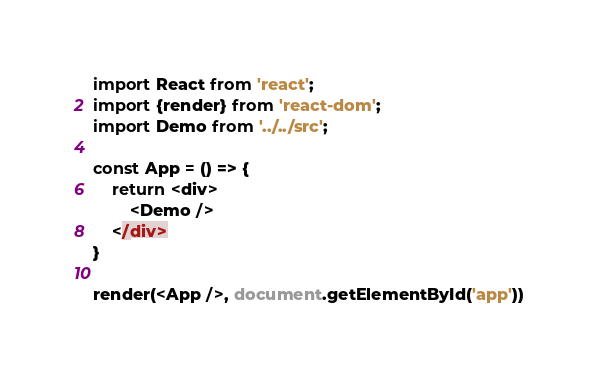<code> <loc_0><loc_0><loc_500><loc_500><_JavaScript_>import React from 'react';
import {render} from 'react-dom';
import Demo from '../../src';

const App = () => {
    return <div>
        <Demo />
    </div>
}

render(<App />, document.getElementById('app'))</code> 